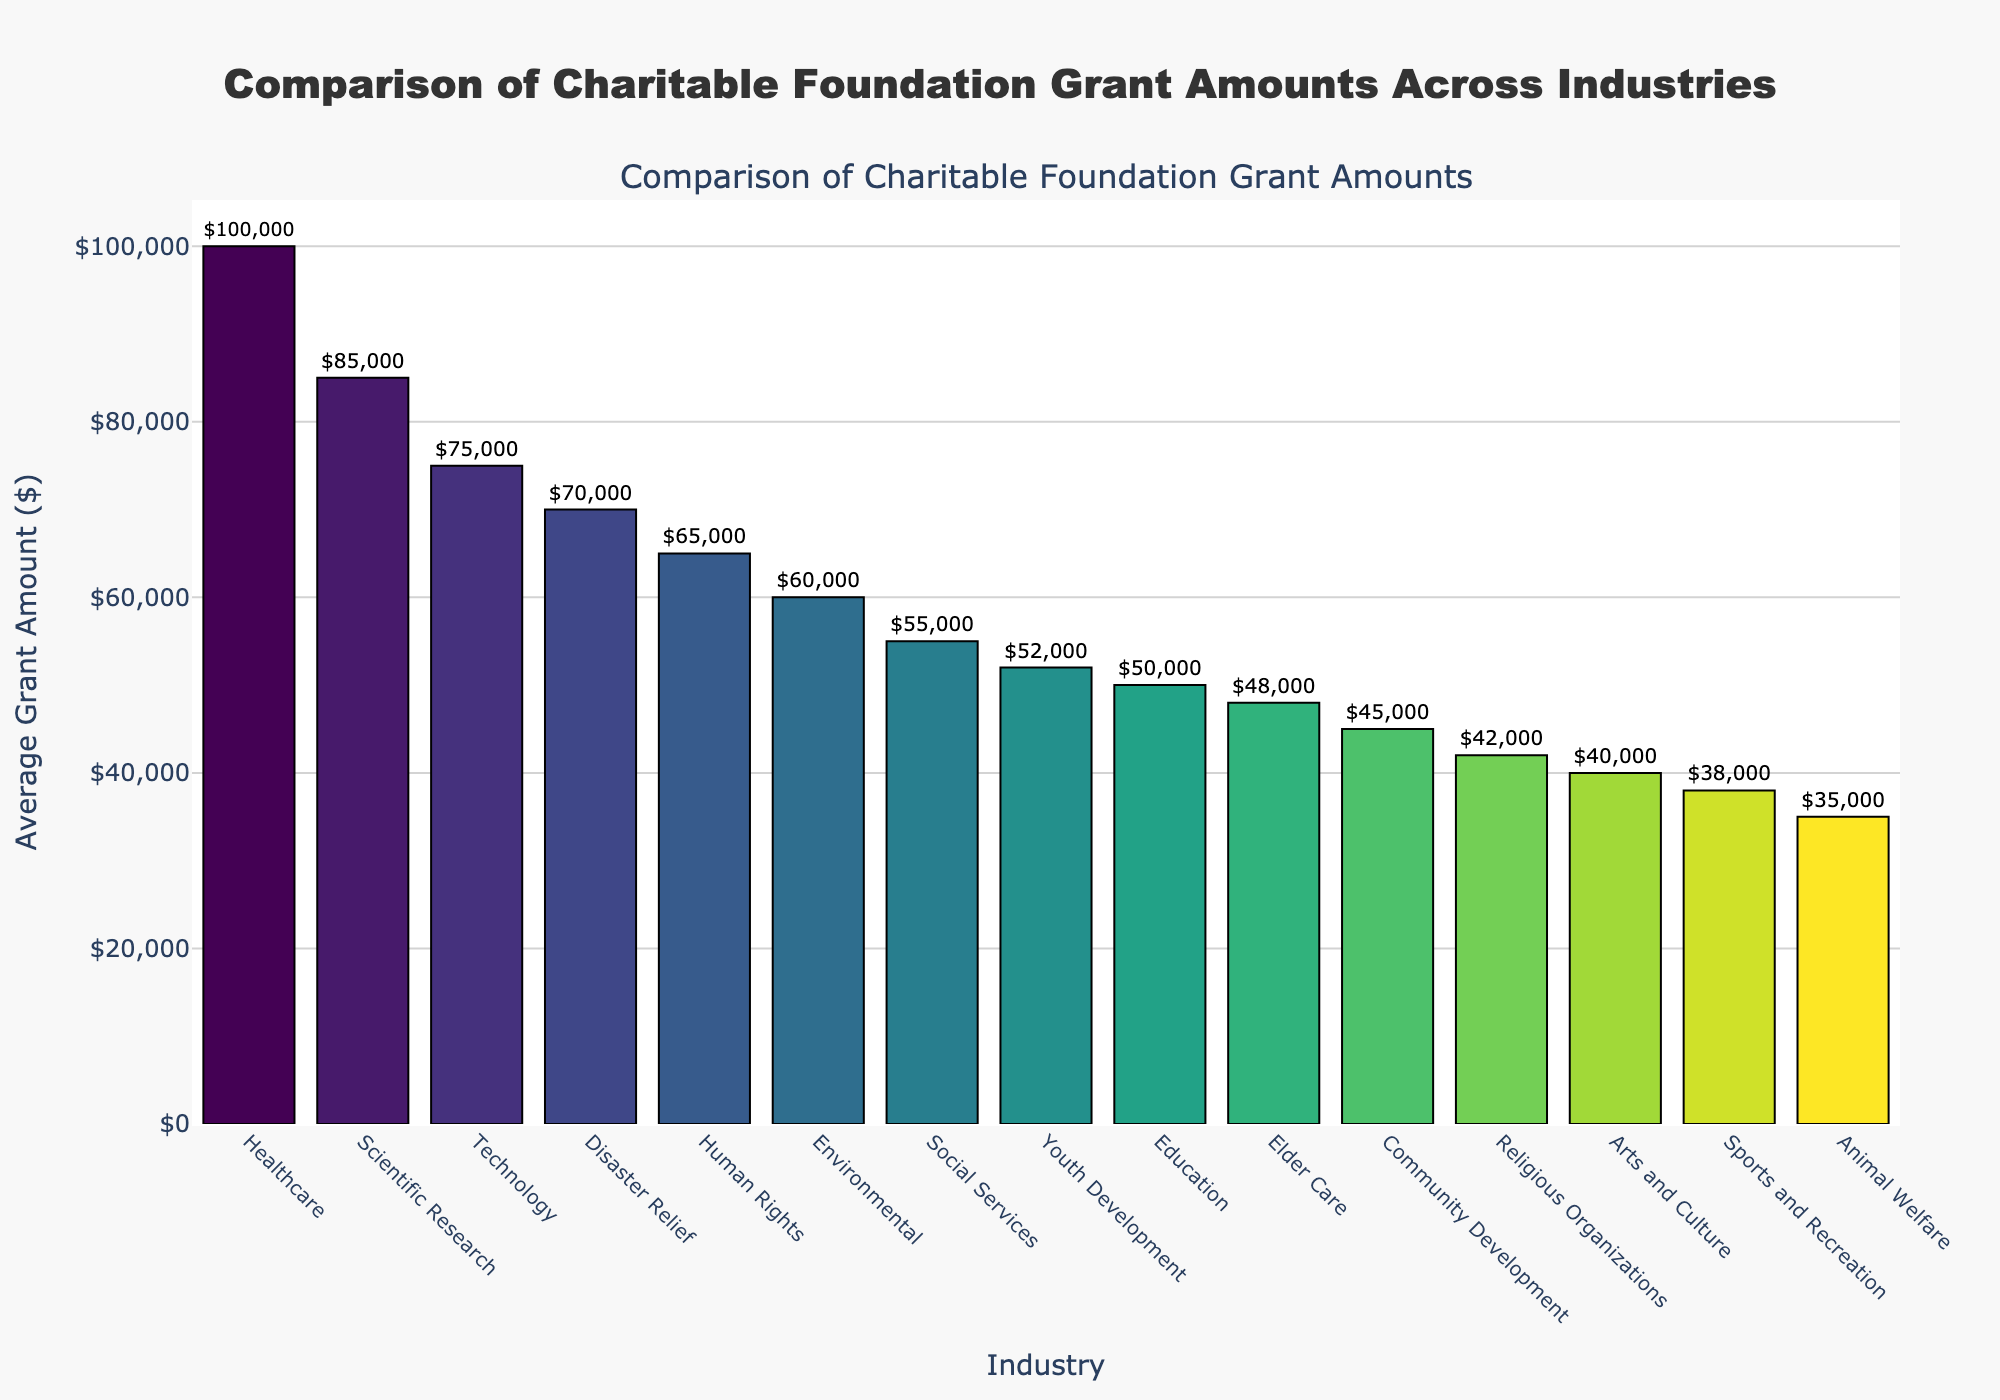Which industry receives the highest average grant amount? The industry with the highest bar represents the industry that receives the highest average grant amount. From the chart, Healthcare has the highest bar.
Answer: Healthcare Which two industries receive the lowest average grant amounts? The industries with the shortest bars represent those receiving the lowest average grant amounts. In the chart, Animal Welfare and Arts and Culture have the shortest bars.
Answer: Animal Welfare, Arts and Culture What is the difference in average grant amount between the Technology and Scientific Research industries? The bars representing Technology and Scientific Research show their respective average grant amounts. Technology receives $75,000 and Scientific Research receives $85,000. The difference is $85,000 - $75,000.
Answer: $10,000 Is the average grant amount for Youth Development higher than for Elder Care? By comparing the height of the bars for Youth Development and Elder Care, we can see that the Youth Development bar is taller, representing a higher average grant amount.
Answer: Yes Combine the average grant amounts for Environmental and Disaster Relief industries. What is the total? From the chart, Environmental has $60,000 and Disaster Relief has $70,000. The sum is $60,000 + $70,000.
Answer: $130,000 Does the Social Services industry receive more or less than $60,000 on average? The bar for Social Services shows the average grant amount, and visually it falls below the $60,000 mark.
Answer: Less How much more does the Human Rights industry receive on average compared to the Religious Organizations industry? The bars for Human Rights and Religious Organizations show their average grant amounts as $65,000 and $42,000, respectively. The difference is $65,000 - $42,000.
Answer: $23,000 What is the average grant amount for industries starting with the letter 'A'? The industries starting with 'A' are Arts and Culture ($40,000) and Animal Welfare ($35,000). The average is calculated as (40,000 + 35,000) / 2.
Answer: $37,500 Is there any industry that receives exactly $50,000 as an average grant amount? By examining the chart, we see that the Education industry receives exactly $50,000.
Answer: Yes, Education Rank the top three industries by average grant amount and list their respective amounts. The three tallest bars represent the top three industries. Healthcare ($100,000), Scientific Research ($85,000), and Technology ($75,000) have the highest average grant amounts.
Answer: Healthcare: $100,000, Scientific Research: $85,000, Technology: $75,000 